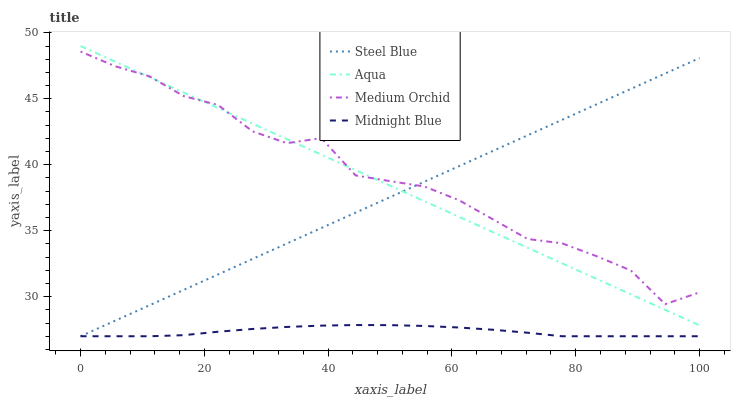Does Midnight Blue have the minimum area under the curve?
Answer yes or no. Yes. Does Medium Orchid have the maximum area under the curve?
Answer yes or no. Yes. Does Aqua have the minimum area under the curve?
Answer yes or no. No. Does Aqua have the maximum area under the curve?
Answer yes or no. No. Is Steel Blue the smoothest?
Answer yes or no. Yes. Is Medium Orchid the roughest?
Answer yes or no. Yes. Is Aqua the smoothest?
Answer yes or no. No. Is Aqua the roughest?
Answer yes or no. No. Does Aqua have the lowest value?
Answer yes or no. No. Does Aqua have the highest value?
Answer yes or no. Yes. Does Steel Blue have the highest value?
Answer yes or no. No. Is Midnight Blue less than Aqua?
Answer yes or no. Yes. Is Medium Orchid greater than Midnight Blue?
Answer yes or no. Yes. Does Medium Orchid intersect Aqua?
Answer yes or no. Yes. Is Medium Orchid less than Aqua?
Answer yes or no. No. Is Medium Orchid greater than Aqua?
Answer yes or no. No. Does Midnight Blue intersect Aqua?
Answer yes or no. No. 